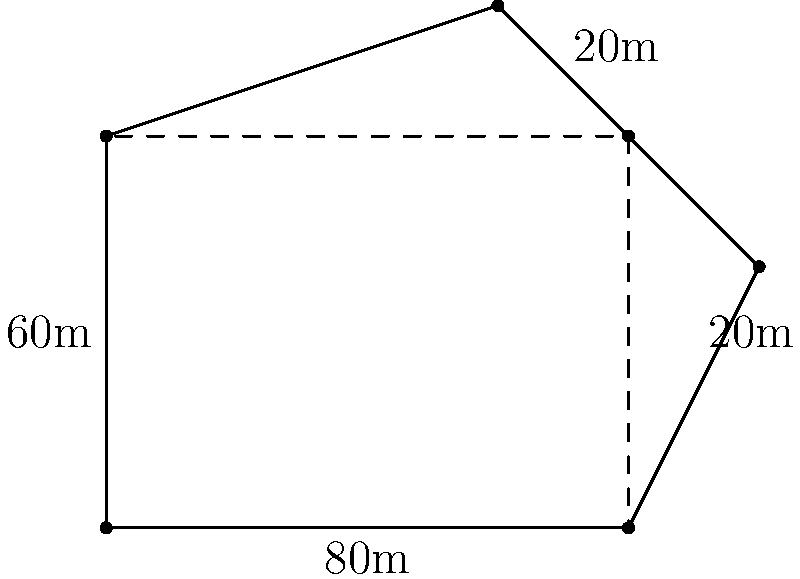You need to estimate the area of an irregularly shaped parking lot at a rest stop along BR-267. The lot can be approximated using a rectangle and two right triangles, as shown in the diagram. If the main rectangle measures 80m by 60m, and both triangles have a base of 20m and a height of 20m, what is the estimated area of the parking lot in square meters? To estimate the area of the irregularly shaped parking lot, we'll break it down into simpler geometric shapes and calculate their areas:

1. Calculate the area of the main rectangle:
   $A_{rectangle} = length \times width = 80m \times 60m = 4800m^2$

2. Calculate the area of each right triangle:
   $A_{triangle} = \frac{1}{2} \times base \times height = \frac{1}{2} \times 20m \times 20m = 200m^2$

3. Since there are two identical triangles, multiply the area of one triangle by 2:
   $A_{two triangles} = 200m^2 \times 2 = 400m^2$

4. Sum up the areas of the rectangle and the two triangles:
   $A_{total} = A_{rectangle} + A_{two triangles} = 4800m^2 + 400m^2 = 5200m^2$

Therefore, the estimated area of the parking lot is 5200 square meters.
Answer: $5200m^2$ 